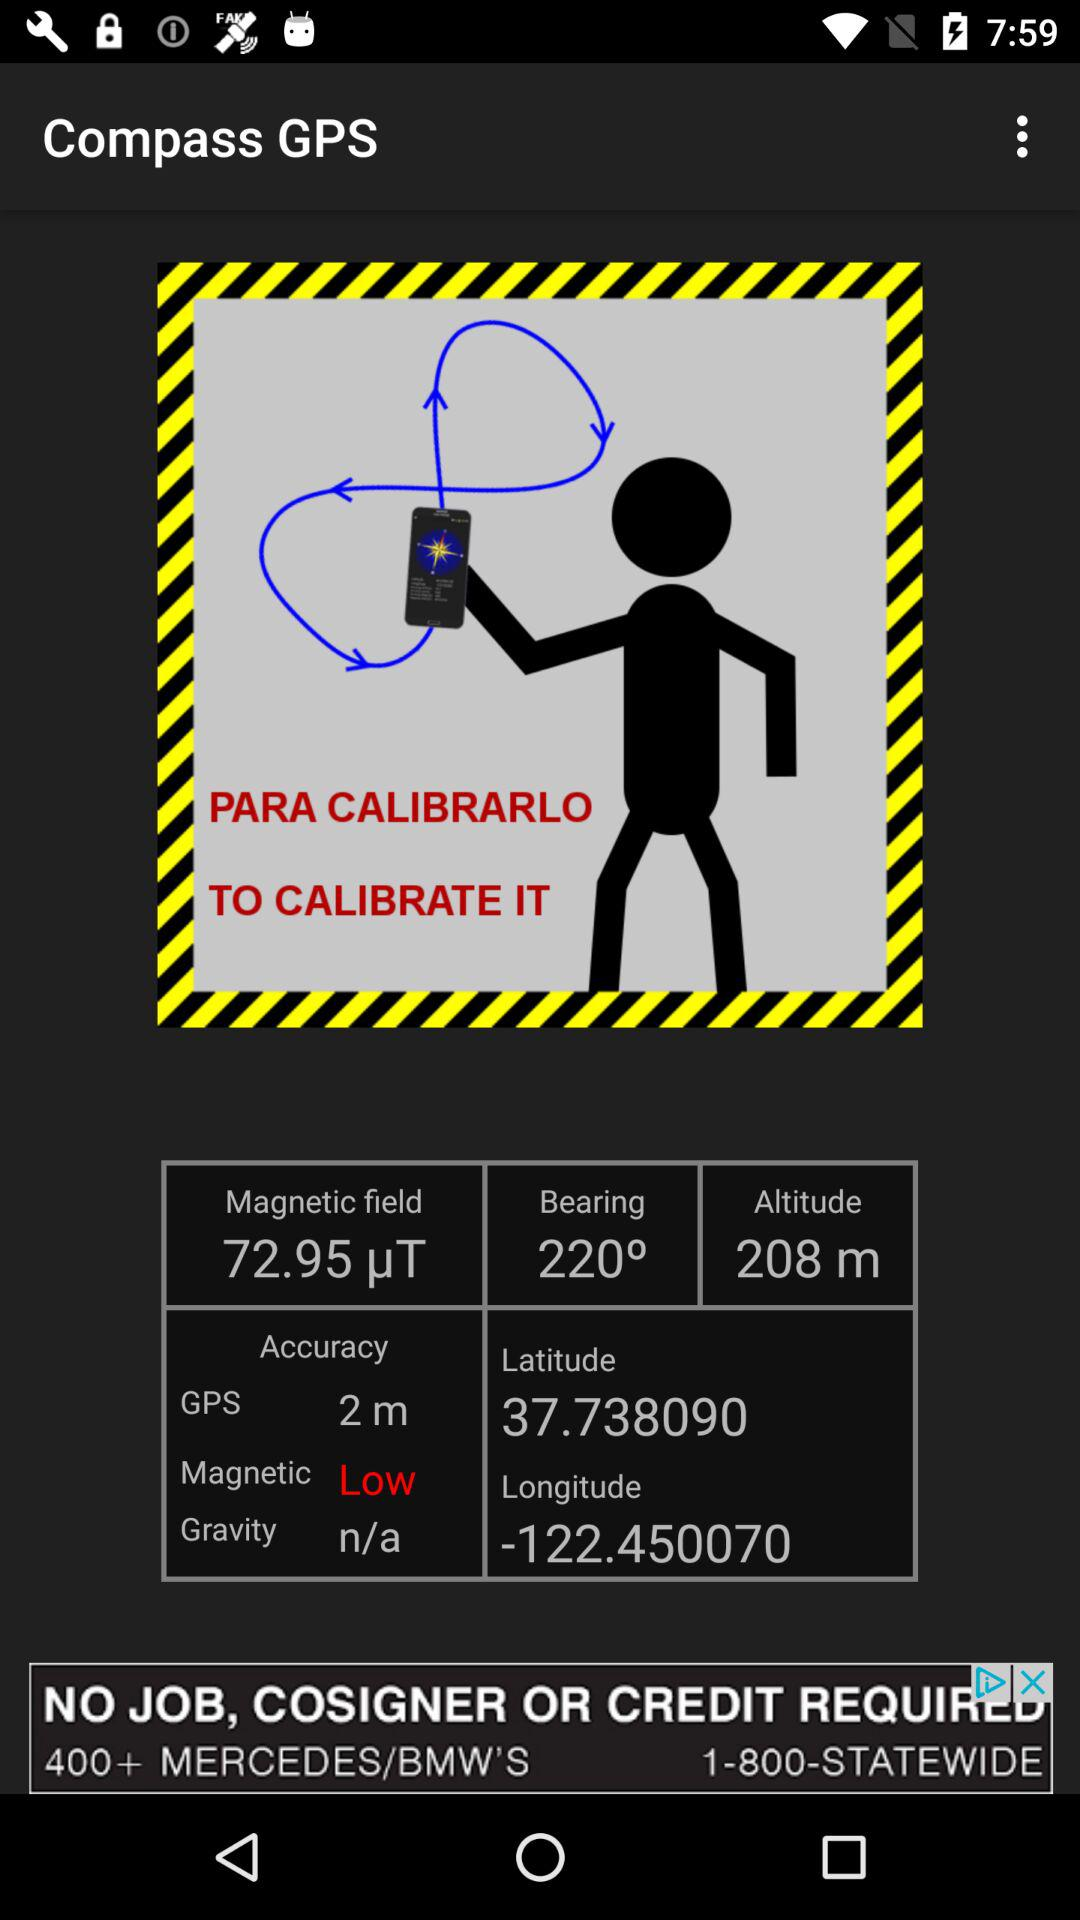What is the altitude? The altitude is 208 m. 